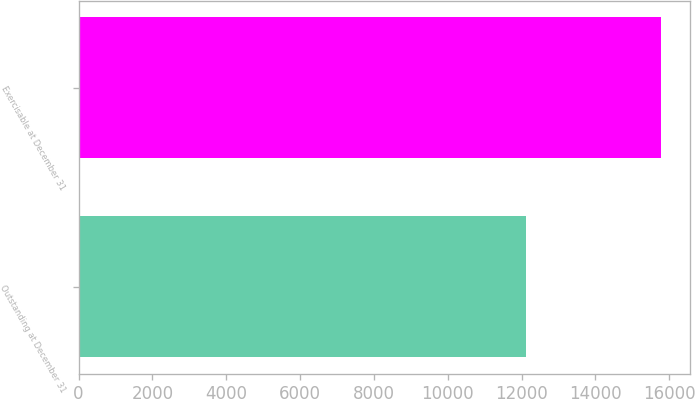Convert chart. <chart><loc_0><loc_0><loc_500><loc_500><bar_chart><fcel>Outstanding at December 31<fcel>Exercisable at December 31<nl><fcel>12121<fcel>15773<nl></chart> 